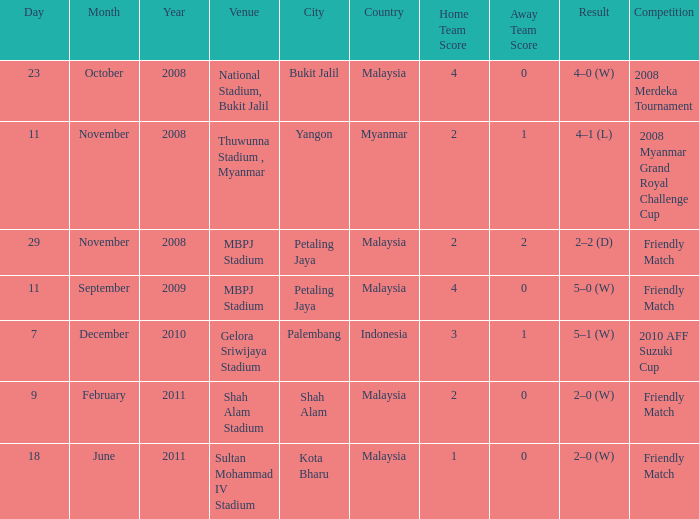What Competition in Shah Alam Stadium have a Result of 2–0 (w)? Friendly Match. 